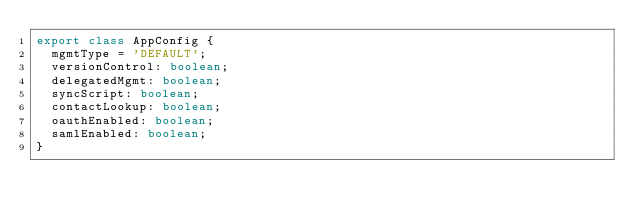<code> <loc_0><loc_0><loc_500><loc_500><_TypeScript_>export class AppConfig {
  mgmtType = 'DEFAULT';
  versionControl: boolean;
  delegatedMgmt: boolean;
  syncScript: boolean;
  contactLookup: boolean;
  oauthEnabled: boolean;
  samlEnabled: boolean;
}
</code> 